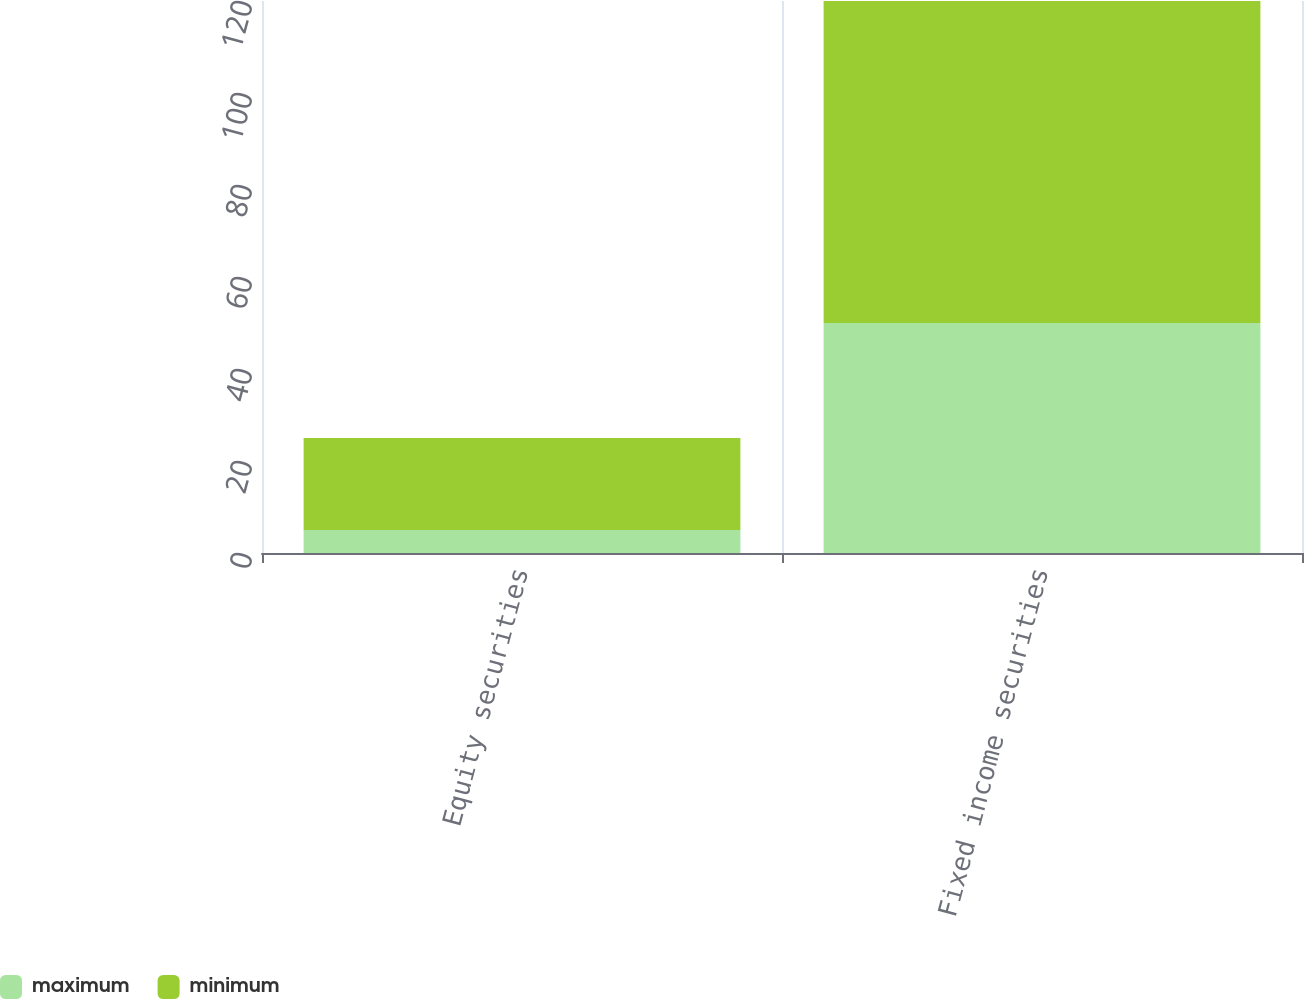Convert chart to OTSL. <chart><loc_0><loc_0><loc_500><loc_500><stacked_bar_chart><ecel><fcel>Equity securities<fcel>Fixed income securities<nl><fcel>maximum<fcel>5<fcel>50<nl><fcel>minimum<fcel>20<fcel>70<nl></chart> 